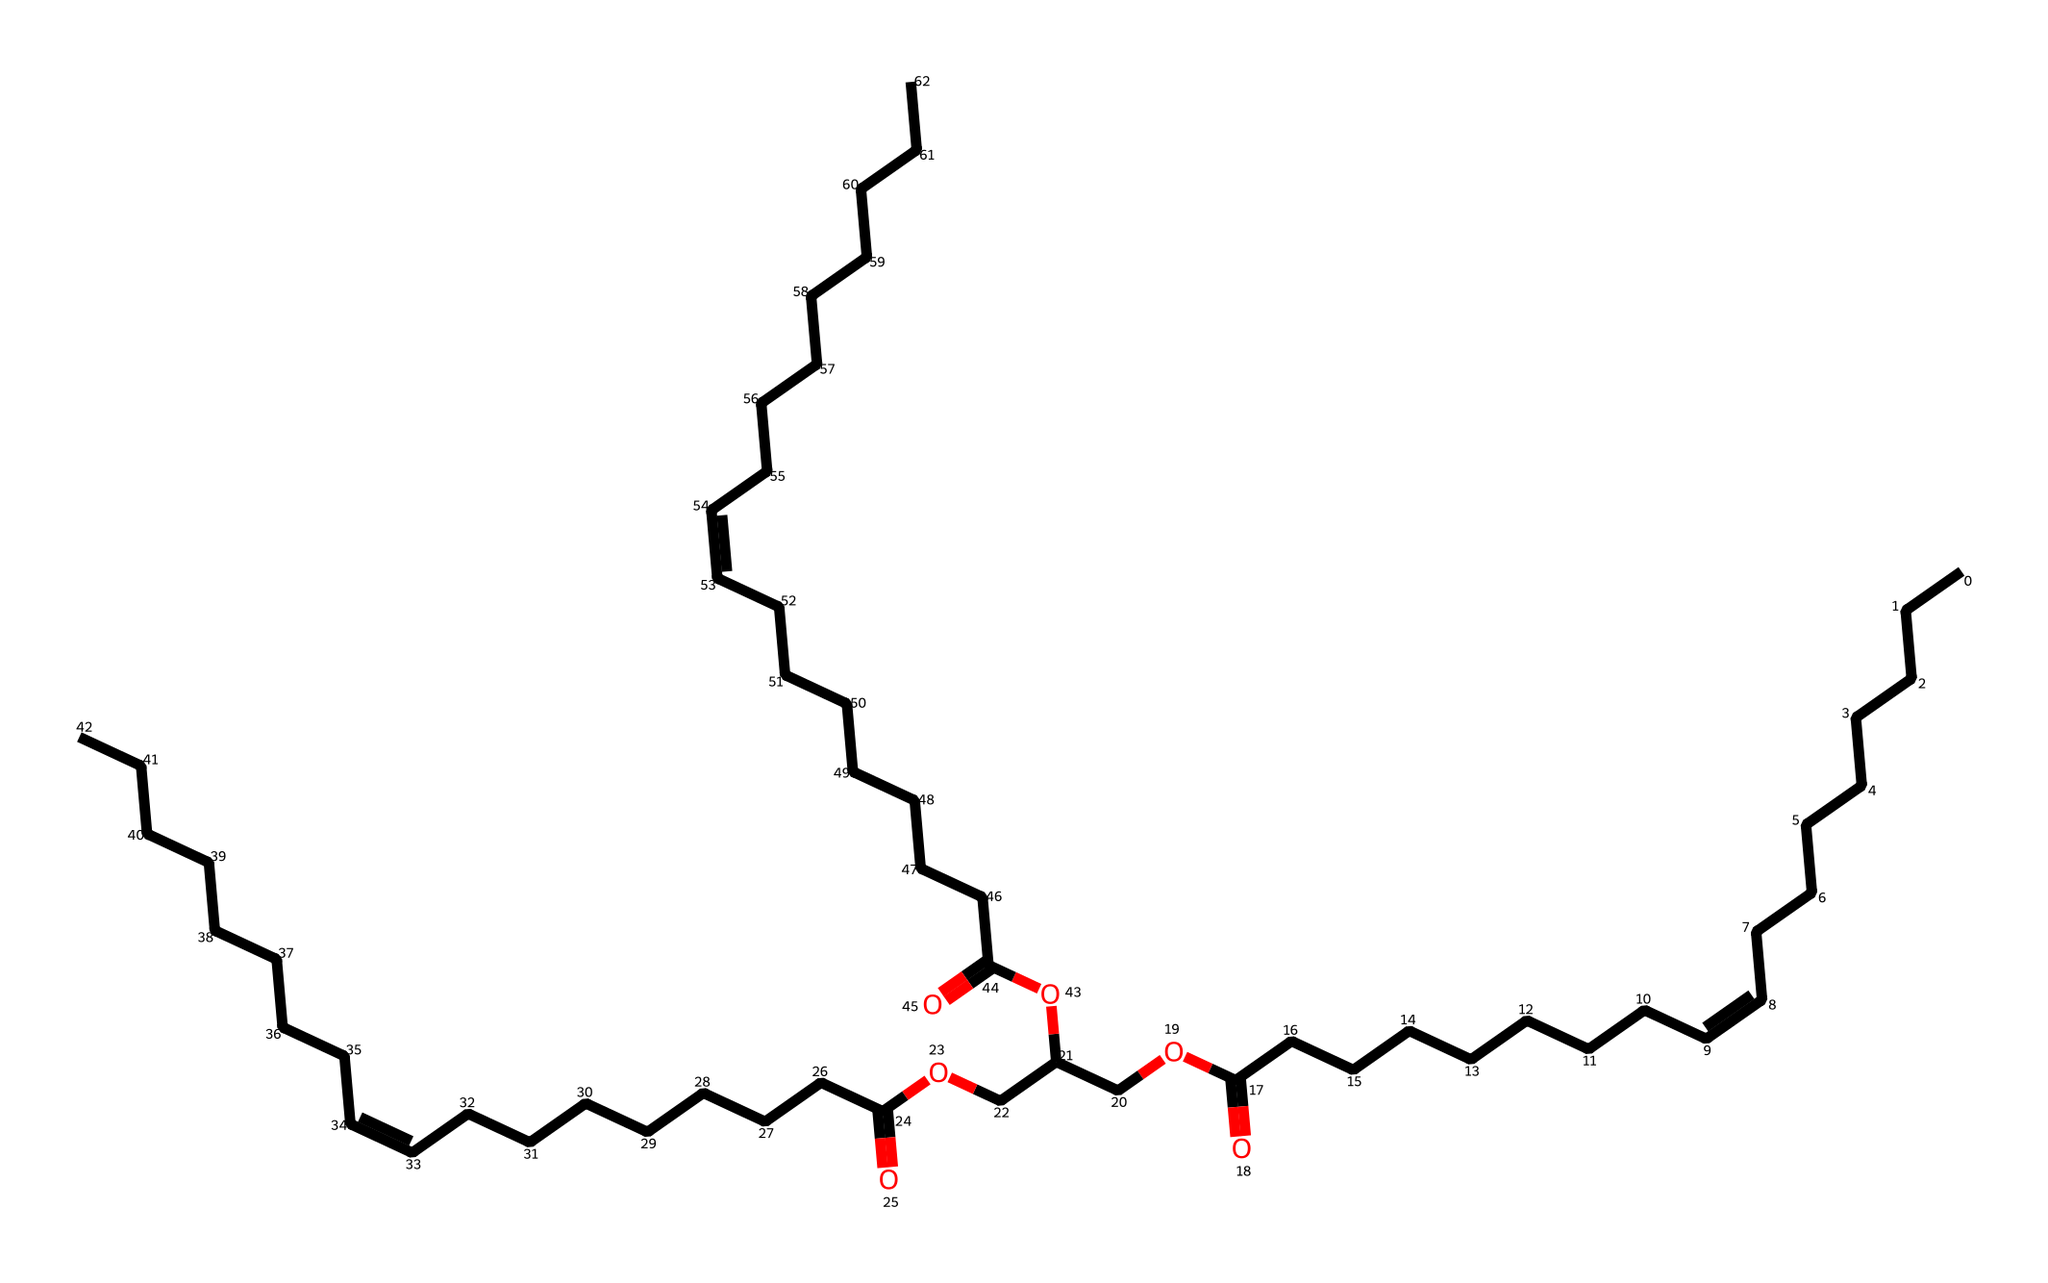How many carbon atoms are present in this molecule? By observing the SMILES representation, we count the number of carbon (C) characters in the structure. Each chain and ring in the SMILES contributes to the total count of carbon atoms, leading to a total of 56.
Answer: 56 What functional group is present in this structure? The presence of the carboxylic acid functional group is indicated by the "C(=O)O" portion of the SMILES. This shows a carbon double-bonded to an oxygen atom (the carbonyl) and single-bonded to a hydroxyl group (the -OH).
Answer: carboxylic acid What type of lipid does this SMILES represent? The structure contains multiple fatty acid chains and is esterified with glycerol, indicating that it represents a triacylglycerol (triglyceride), which is a common type of lipid found in olive oil.
Answer: triacylglycerol How many double bonds are present in the fatty acid chains? By analyzing the "/C=C\" portions in the SMILES, we can identify three double bonds present in the structure, meaning there are three unsaturated fatty acid chains.
Answer: 3 What is the average degree of unsaturation for the fatty acids in this structure? Each double bond contributes to one degree of unsaturation. Given that there are three double bonds and this is a triglyceride made from three fatty acids, the average degree of unsaturation is determined to be three.
Answer: 3 Which part of the structure indicates its use in preserving food? The presence of the ester linkages (the -O- segments connecting the fatty acid chains to the glycerol backbone) signifies that the lipids can be used as preservatives, as they help to stabilize the oils and prevent spoilage through oxidation.
Answer: ester linkages 